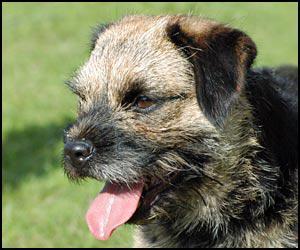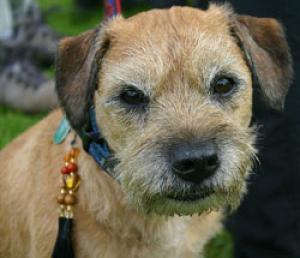The first image is the image on the left, the second image is the image on the right. For the images shown, is this caption "Each dog is outside in the grass." true? Answer yes or no. Yes. The first image is the image on the left, the second image is the image on the right. Considering the images on both sides, is "Each image shows the face of one dog, but only the lefthand image features a dog with an open mouth." valid? Answer yes or no. Yes. 